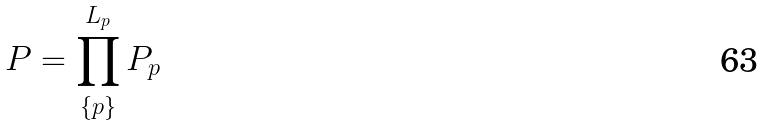<formula> <loc_0><loc_0><loc_500><loc_500>P = \prod _ { \{ p \} } ^ { L _ { p } } P _ { p }</formula> 